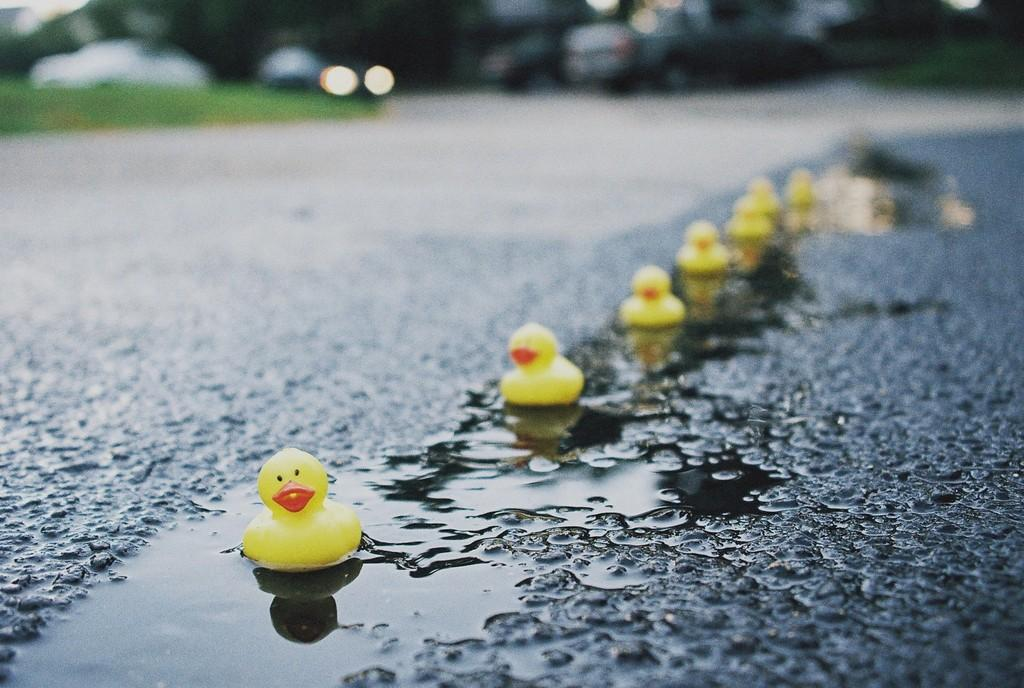What type of toys are on the floor in the image? There are toy ducks on the floor in the image. What other objects can be seen in the image? There are cars in the image. What type of natural elements are present in the image? There are trees in the image. What is the price of the necklace worn by the carriage driver in the image? There is no necklace or carriage driver present in the image. 